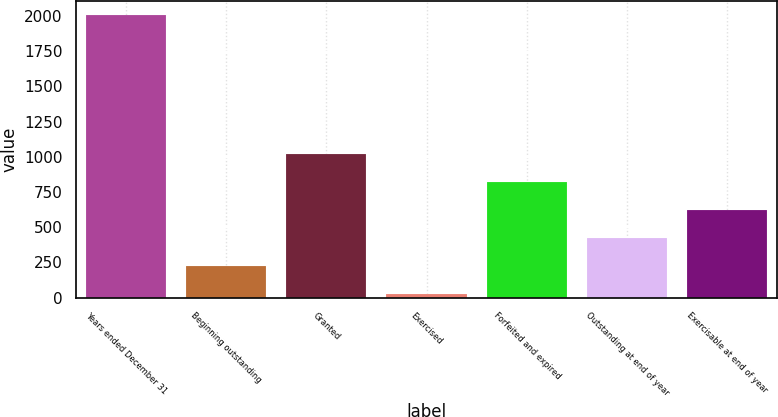<chart> <loc_0><loc_0><loc_500><loc_500><bar_chart><fcel>Years ended December 31<fcel>Beginning outstanding<fcel>Granted<fcel>Exercised<fcel>Forfeited and expired<fcel>Outstanding at end of year<fcel>Exercisable at end of year<nl><fcel>2007<fcel>226.8<fcel>1018<fcel>29<fcel>820.2<fcel>424.6<fcel>622.4<nl></chart> 